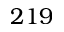Convert formula to latex. <formula><loc_0><loc_0><loc_500><loc_500>2 1 9</formula> 